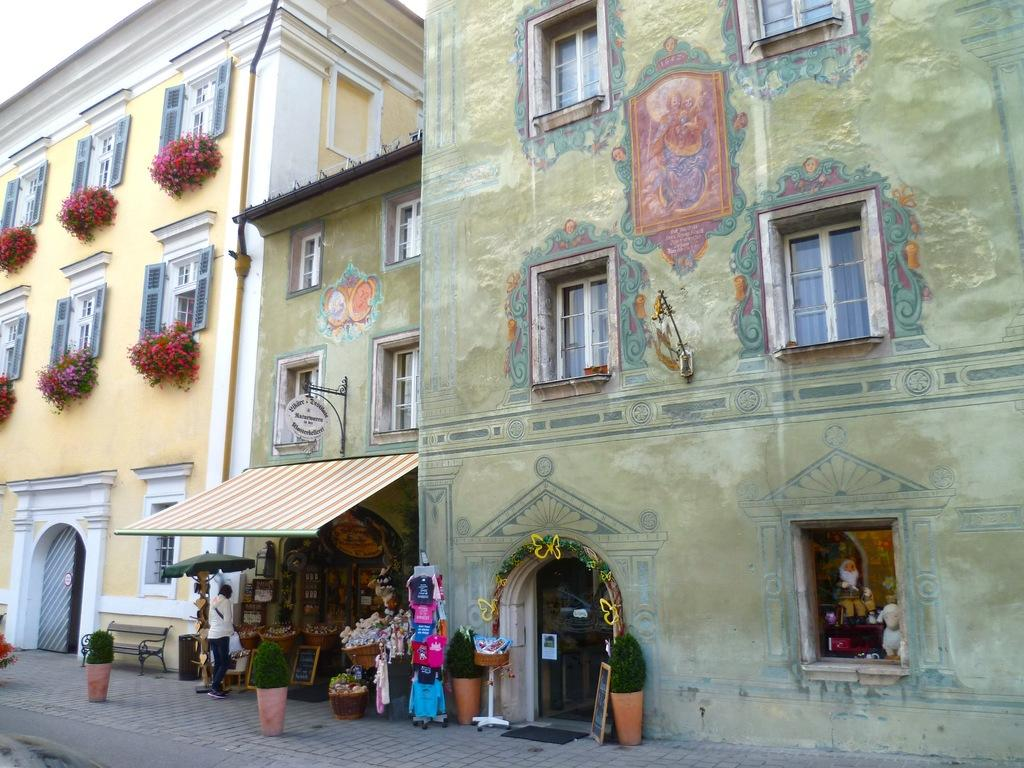What type of structures can be seen on the right side of the image? There are buildings on the right side of the image. What type of vegetation is present in the image? There are plants and flowers in the image. What architectural features can be seen in the image? There are windows visible in the image. Who or what is present at the bottom of the image? There are people, posters, and toys at the bottom of the image. What is the surface that the people, posters, and toys are resting on? There is a floor visible in the image. What is visible at the top of the image? The sky is visible at the top of the image. Can you see a squirrel using magic to levitate the toys in the image? No, there is no squirrel or magic present in the image. The toys are resting on the floor, and there are no levitating objects. 